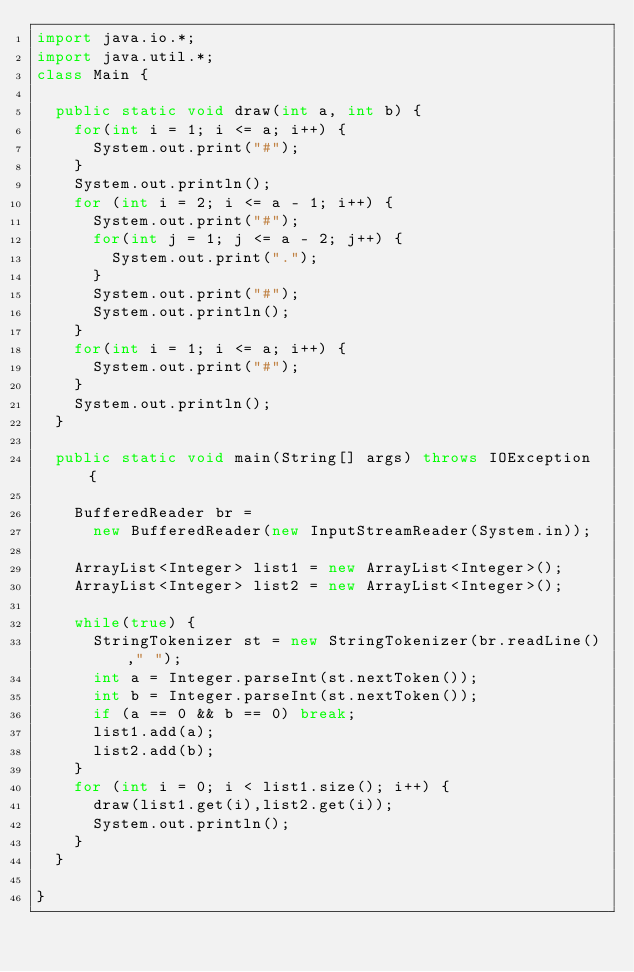Convert code to text. <code><loc_0><loc_0><loc_500><loc_500><_Java_>import java.io.*;
import java.util.*;
class Main {
	
	public static void draw(int a, int b) {
		for(int i = 1; i <= a; i++) {
			System.out.print("#");
		}
		System.out.println();
		for (int i = 2; i <= a - 1; i++) {
			System.out.print("#");
			for(int j = 1; j <= a - 2; j++) {
				System.out.print(".");
			}
			System.out.print("#");
			System.out.println();
		}
		for(int i = 1; i <= a; i++) {
			System.out.print("#");
		}
		System.out.println();
	}
	
	public static void main(String[] args) throws IOException {
		
		BufferedReader br = 
			new BufferedReader(new InputStreamReader(System.in));
		
		ArrayList<Integer> list1 = new ArrayList<Integer>();
		ArrayList<Integer> list2 = new ArrayList<Integer>();
		
		while(true) {
			StringTokenizer st = new StringTokenizer(br.readLine()," ");
			int a = Integer.parseInt(st.nextToken());
			int b = Integer.parseInt(st.nextToken());
			if (a == 0 && b == 0) break;
			list1.add(a);
			list2.add(b);
		}
		for (int i = 0; i < list1.size(); i++) {
			draw(list1.get(i),list2.get(i));
			System.out.println();
		}
	}
	
}</code> 